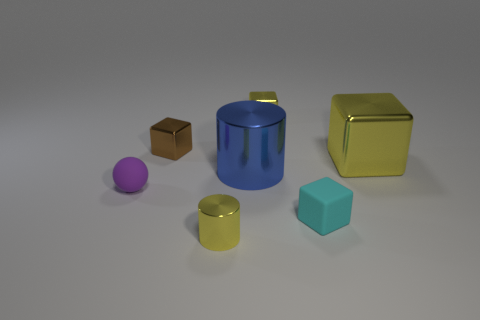Does the small sphere have the same color as the large metal block?
Your answer should be compact. No. What number of green objects are small things or blocks?
Your response must be concise. 0. There is a purple ball that is the same size as the cyan rubber block; what material is it?
Offer a terse response. Rubber. There is a small thing that is behind the big yellow metal cube and to the right of the brown metal cube; what shape is it?
Keep it short and to the point. Cube. The cube that is the same size as the blue cylinder is what color?
Keep it short and to the point. Yellow. There is a metallic object on the left side of the yellow metal cylinder; is its size the same as the yellow shiny cube that is in front of the small brown metallic cube?
Give a very brief answer. No. What is the size of the yellow metal object in front of the metallic object on the right side of the block that is in front of the tiny matte ball?
Provide a succinct answer. Small. There is a metallic thing that is right of the matte thing that is right of the tiny brown thing; what shape is it?
Give a very brief answer. Cube. Does the cylinder in front of the small cyan matte cube have the same color as the big block?
Your answer should be very brief. Yes. What color is the thing that is both behind the cyan matte cube and in front of the blue metallic cylinder?
Provide a short and direct response. Purple. 